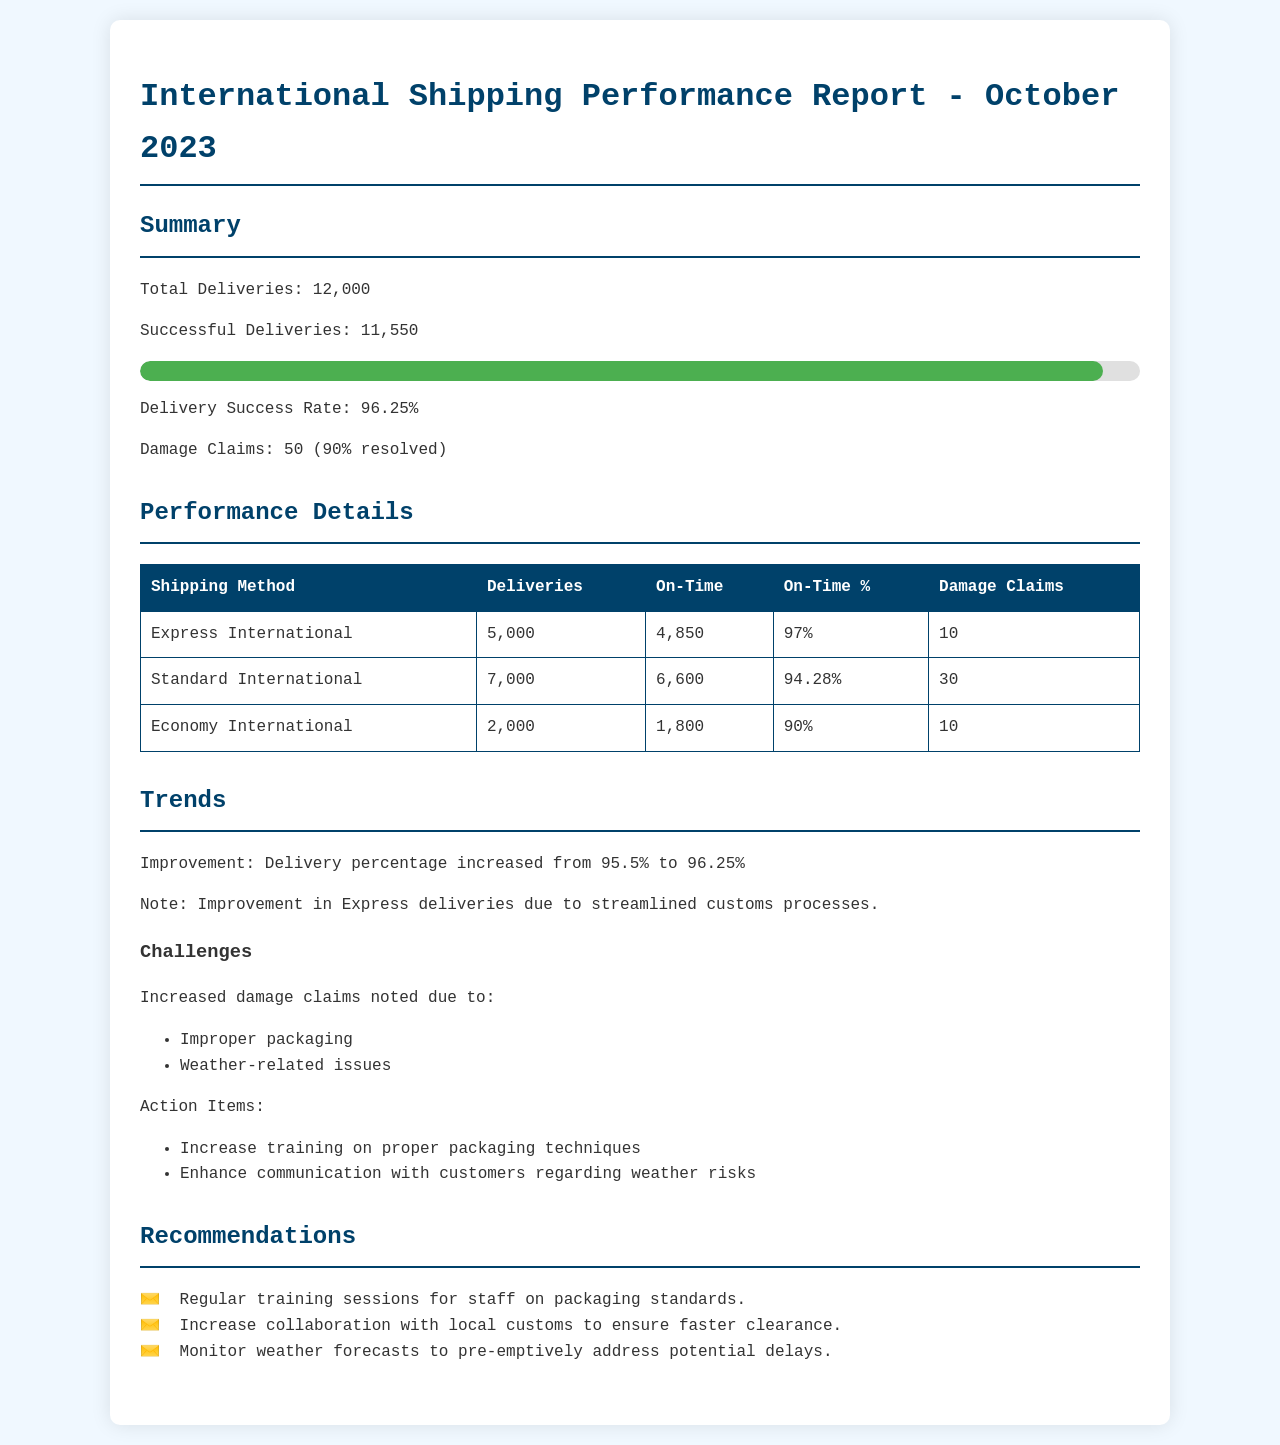What is the total number of deliveries? The total number of deliveries is stated in the summary section of the document.
Answer: 12,000 What is the delivery success rate? The delivery success rate is calculated based on successful deliveries out of total deliveries.
Answer: 96.25% How many damage claims were reported? The total damage claims are mentioned in the summary section of the document.
Answer: 50 Which shipping method had the highest on-time percentage? The on-time percentages for each shipping method are listed in the performance details.
Answer: Express International What is the trend in delivery percentage compared to the previous month? The document mentions the improvement in the delivery percentage from last month.
Answer: Increased from 95.5% to 96.25% What challenges increased damage claims? The document lists specific challenges that contributed to increased damage claims.
Answer: Improper packaging, Weather-related issues What is one action item to address improper packaging? The action items for improvement are specified in the trends section.
Answer: Increase training on proper packaging techniques What is one recommendation regarding weather risks? Recommendations are provided for potential issues related to deliveries.
Answer: Monitor weather forecasts to pre-emptively address potential delays 